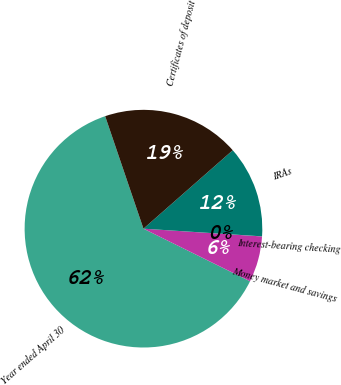<chart> <loc_0><loc_0><loc_500><loc_500><pie_chart><fcel>Year ended April 30<fcel>Money market and savings<fcel>Interest-bearing checking<fcel>IRAs<fcel>Certificates of deposit<nl><fcel>62.48%<fcel>6.26%<fcel>0.01%<fcel>12.5%<fcel>18.75%<nl></chart> 